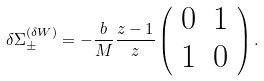Convert formula to latex. <formula><loc_0><loc_0><loc_500><loc_500>\delta { \Sigma } ^ { ( \delta W ) } _ { \pm } = - \frac { b } { M } \frac { z - 1 } { z } \left ( \begin{array} { c c } 0 & 1 \\ 1 & 0 \end{array} \right ) .</formula> 